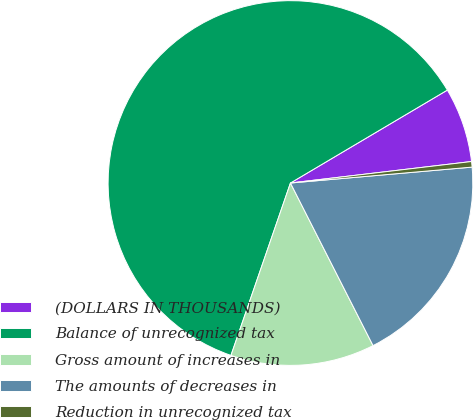<chart> <loc_0><loc_0><loc_500><loc_500><pie_chart><fcel>(DOLLARS IN THOUSANDS)<fcel>Balance of unrecognized tax<fcel>Gross amount of increases in<fcel>The amounts of decreases in<fcel>Reduction in unrecognized tax<nl><fcel>6.63%<fcel>61.2%<fcel>12.77%<fcel>18.91%<fcel>0.49%<nl></chart> 